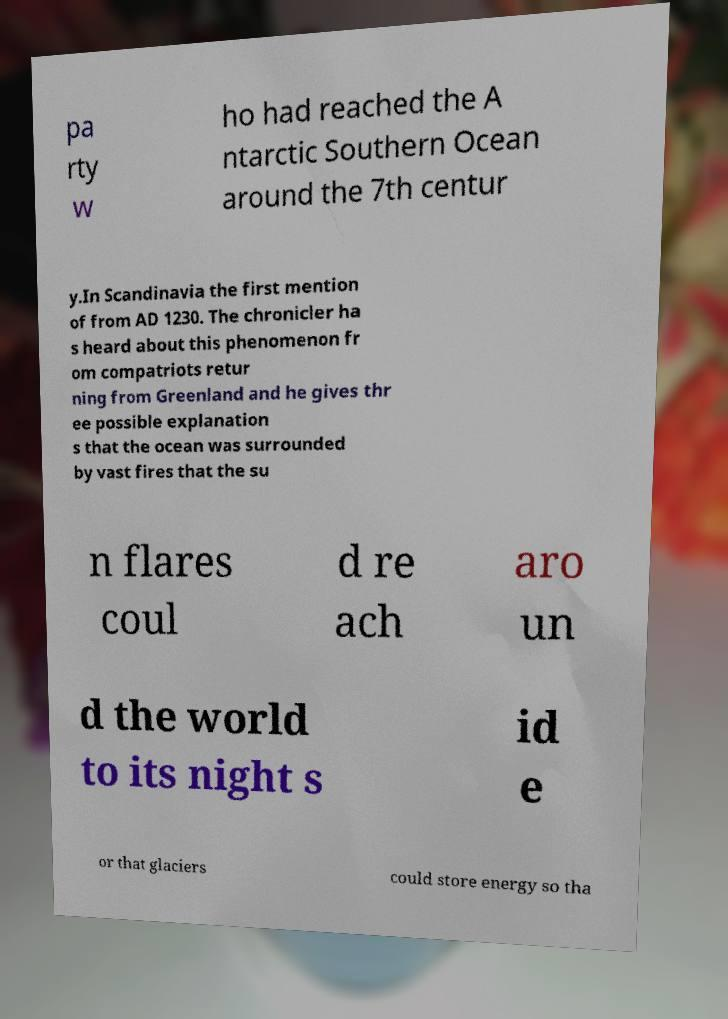There's text embedded in this image that I need extracted. Can you transcribe it verbatim? pa rty w ho had reached the A ntarctic Southern Ocean around the 7th centur y.In Scandinavia the first mention of from AD 1230. The chronicler ha s heard about this phenomenon fr om compatriots retur ning from Greenland and he gives thr ee possible explanation s that the ocean was surrounded by vast fires that the su n flares coul d re ach aro un d the world to its night s id e or that glaciers could store energy so tha 